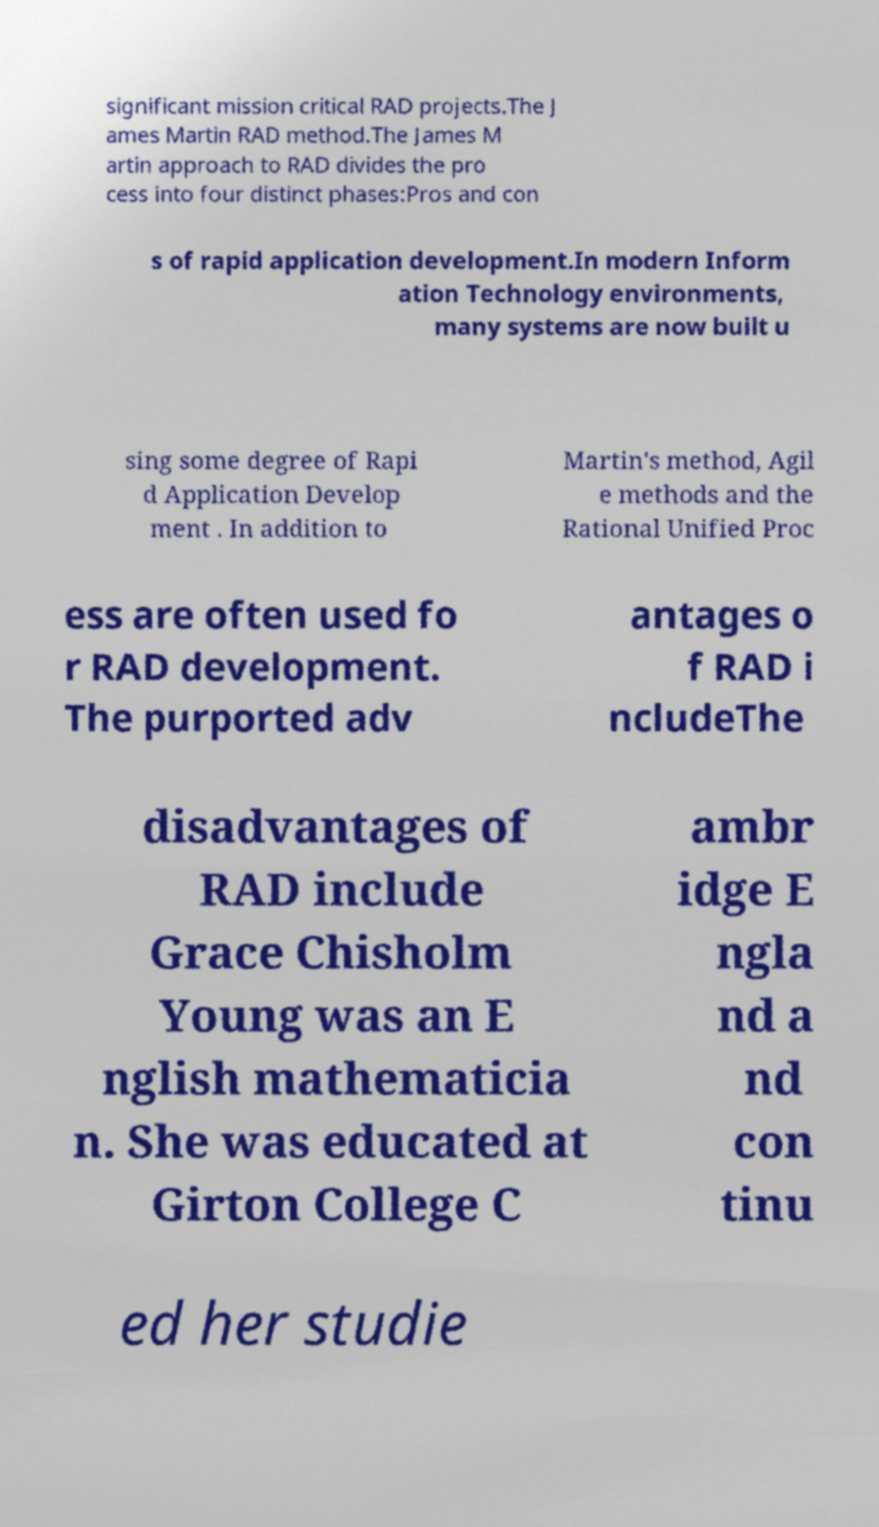Can you read and provide the text displayed in the image?This photo seems to have some interesting text. Can you extract and type it out for me? significant mission critical RAD projects.The J ames Martin RAD method.The James M artin approach to RAD divides the pro cess into four distinct phases:Pros and con s of rapid application development.In modern Inform ation Technology environments, many systems are now built u sing some degree of Rapi d Application Develop ment . In addition to Martin's method, Agil e methods and the Rational Unified Proc ess are often used fo r RAD development. The purported adv antages o f RAD i ncludeThe disadvantages of RAD include Grace Chisholm Young was an E nglish mathematicia n. She was educated at Girton College C ambr idge E ngla nd a nd con tinu ed her studie 